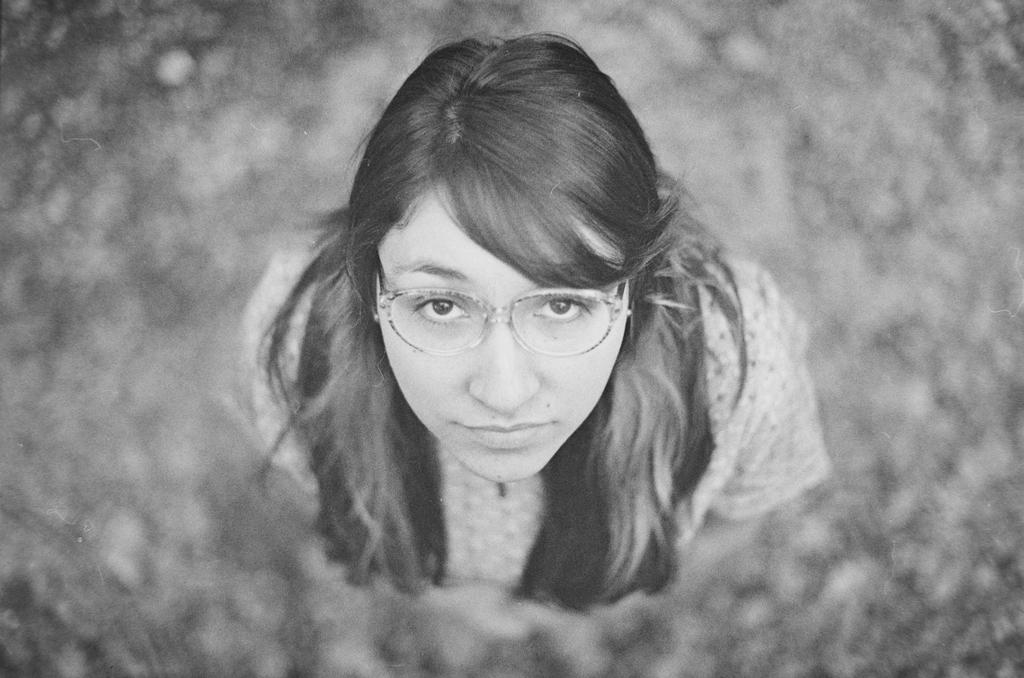What is the main subject of the image? There is a black and white picture of a woman in the image. What is the woman wearing in the image? The woman is wearing a dress in the image. What is the woman doing in the image? The woman is standing in the image. What accessory is the woman wearing in the image? The woman is wearing spectacles in the image. What can be seen in the background of the image? There are blurry objects in the background of the image. What route is the woman taking in the image? The image is a still photograph of a woman standing, so there is no route or movement depicted. What type of land can be seen in the background of the image? The background of the image is blurry, and no specific type of land can be identified. 